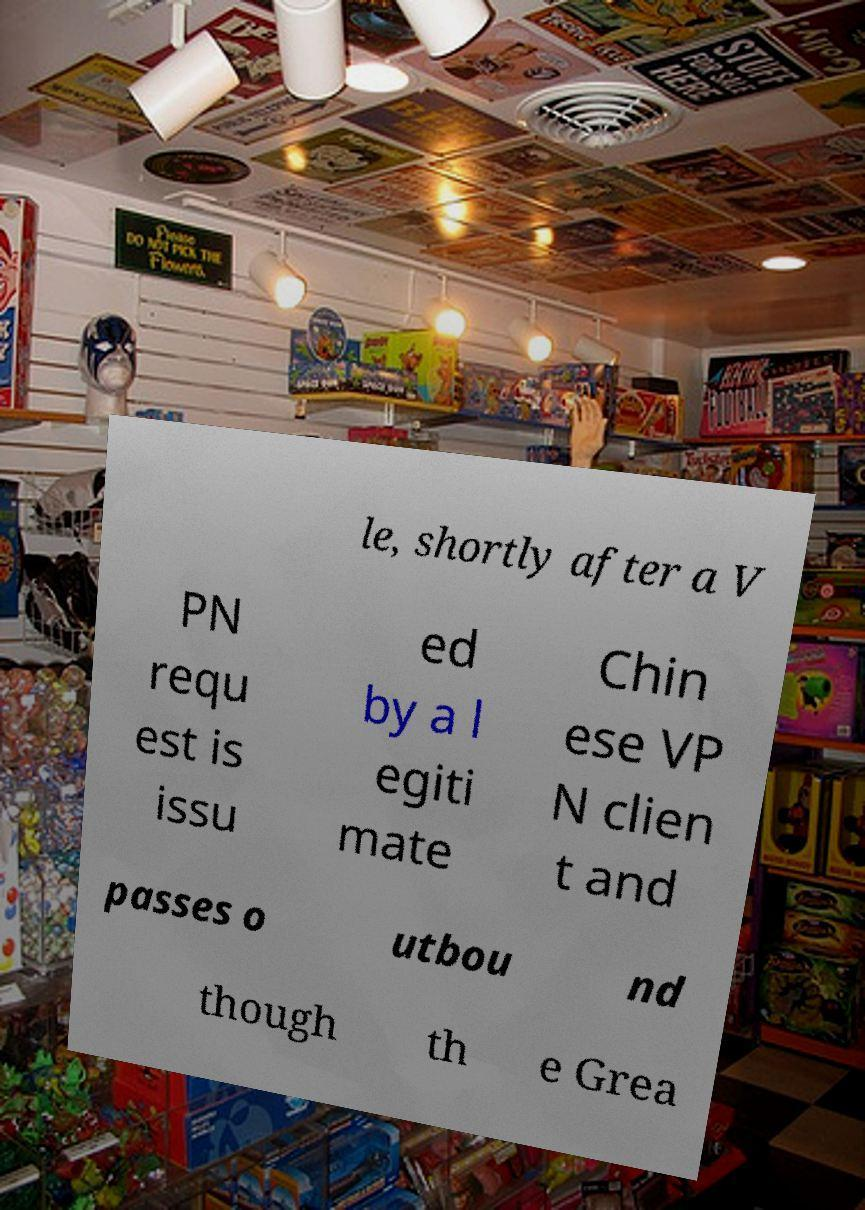Could you extract and type out the text from this image? le, shortly after a V PN requ est is issu ed by a l egiti mate Chin ese VP N clien t and passes o utbou nd though th e Grea 